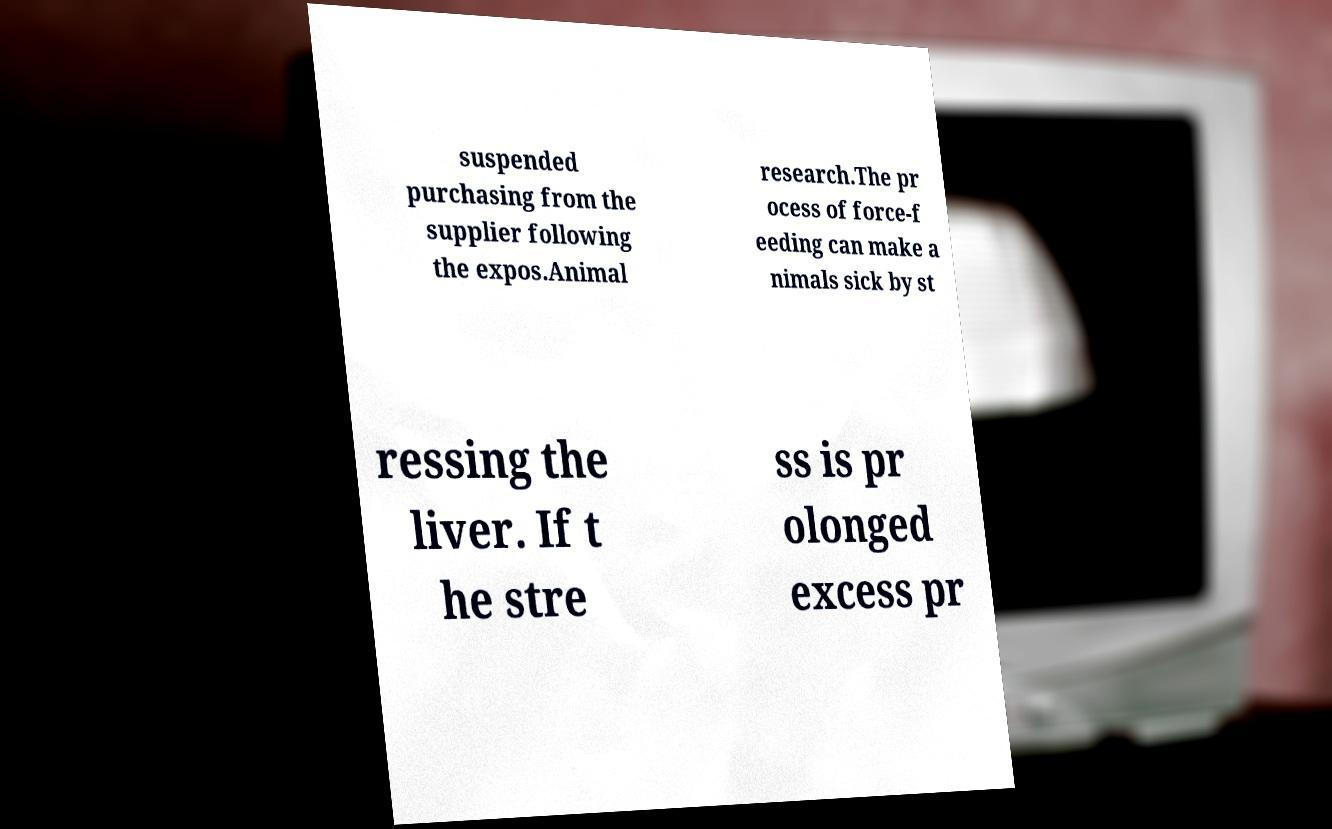For documentation purposes, I need the text within this image transcribed. Could you provide that? suspended purchasing from the supplier following the expos.Animal research.The pr ocess of force-f eeding can make a nimals sick by st ressing the liver. If t he stre ss is pr olonged excess pr 